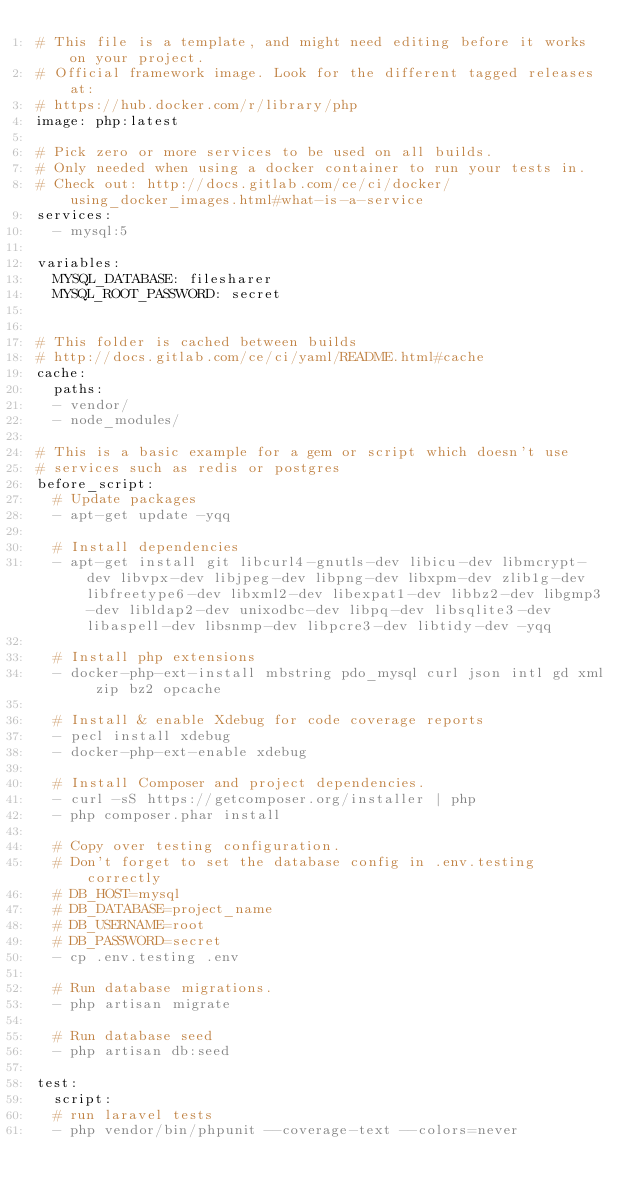<code> <loc_0><loc_0><loc_500><loc_500><_YAML_># This file is a template, and might need editing before it works on your project.
# Official framework image. Look for the different tagged releases at:
# https://hub.docker.com/r/library/php
image: php:latest

# Pick zero or more services to be used on all builds.
# Only needed when using a docker container to run your tests in.
# Check out: http://docs.gitlab.com/ce/ci/docker/using_docker_images.html#what-is-a-service
services:
  - mysql:5

variables:
  MYSQL_DATABASE: filesharer
  MYSQL_ROOT_PASSWORD: secret


# This folder is cached between builds
# http://docs.gitlab.com/ce/ci/yaml/README.html#cache
cache:
  paths:
  - vendor/
  - node_modules/

# This is a basic example for a gem or script which doesn't use
# services such as redis or postgres
before_script:
  # Update packages 
  - apt-get update -yqq
  
  # Install dependencies
  - apt-get install git libcurl4-gnutls-dev libicu-dev libmcrypt-dev libvpx-dev libjpeg-dev libpng-dev libxpm-dev zlib1g-dev libfreetype6-dev libxml2-dev libexpat1-dev libbz2-dev libgmp3-dev libldap2-dev unixodbc-dev libpq-dev libsqlite3-dev libaspell-dev libsnmp-dev libpcre3-dev libtidy-dev -yqq

  # Install php extensions
  - docker-php-ext-install mbstring pdo_mysql curl json intl gd xml zip bz2 opcache

  # Install & enable Xdebug for code coverage reports
  - pecl install xdebug
  - docker-php-ext-enable xdebug

  # Install Composer and project dependencies.
  - curl -sS https://getcomposer.org/installer | php
  - php composer.phar install 

  # Copy over testing configuration.
  # Don't forget to set the database config in .env.testing correctly
  # DB_HOST=mysql
  # DB_DATABASE=project_name
  # DB_USERNAME=root
  # DB_PASSWORD=secret
  - cp .env.testing .env

  # Run database migrations.
  - php artisan migrate

  # Run database seed
  - php artisan db:seed

test:
  script:
  # run laravel tests
  - php vendor/bin/phpunit --coverage-text --colors=never 

</code> 